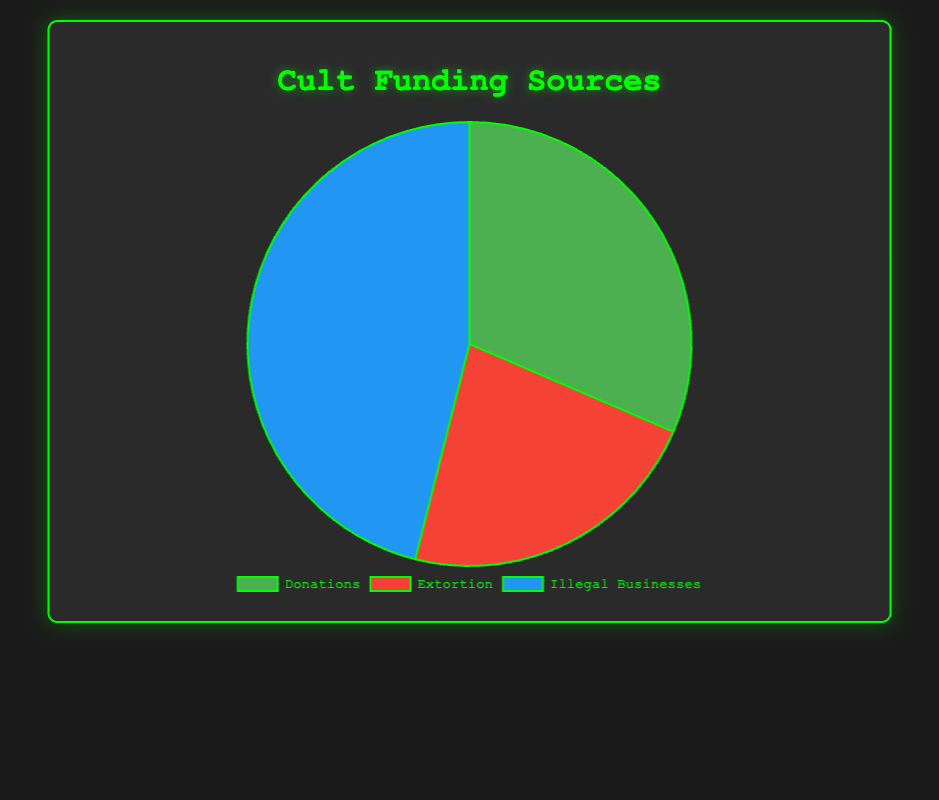what funding category brings in the most money? The pie chart will show the sheer size of each slice, identifying the largest one tells us which category has the highest funding. Look at the slice with the largest area. This represents Illegal Businesses, totaling $410,000.
Answer: Illegal Businesses how much more money does Donations bring in compared to Extortion? First, identify the total amount for Donations ($280,000) and Extortion ($200,000) from the legend. Subtract the Extortion total from the Donations total: 280,000 - 200,000 = 80,000.
Answer: $80,000 what proportion of total funding comes from Illegal Businesses? Sum up all funding sources to get the total: $280,000 (Donations) + $200,000 (Extortion) + $410,000 (Illegal Businesses) = $890,000. The proportion of Illegal Businesses is 410,000 / 890,000 = 0.4607, approximately 46.07%.
Answer: 46.07% which funding source within Illegal Businesses brings in the most money? Within the Illegal Businesses category, check the amounts: Drug Trafficking ($150,000), Human Trafficking ($100,000), Arms Smuggling ($70,000), Counterfeit Goods ($40,000), and Money Laundering ($50,000). The highest amount is for Drug Trafficking.
Answer: Drug Trafficking how does the combined amount from Protection Money and Ransom compare to Individual Donations? Add the amounts for Protection Money ($100,000) and Ransom ($80,000) to get $180,000. Compare this to the amount for Individual Donations ($200,000). Individual Donations are higher.
Answer: Individual Donations are higher what is the funding source with the smallest amount? Identify the smallest individual amount from the list of entities: Charity Events ($30,000), Threatening Letters ($20,000), and Counterfeit Goods ($40,000), etc. Threatening Letters with $20,000 is the smallest.
Answer: Threatening Letters what is the difference between the highest and lowest funding source amounts? Highest amount is Individual Donations ($200,000) and lowest is Threatening Letters ($20,000). Subtract to find the difference: 200,000 - 20,000 = 180,000.
Answer: $180,000 what percentage of Total Funding comes from Donations? Total donations are $280,000. Total funding is $890,000. Calculate the percentage: (280,000 / 890,000) * 100 = 31.46%.
Answer: 31.46% which category has more than twice the funding of Extortion? Determine the amount for Extortion ($200,000). Find categories higher than 200,000 * 2 = 400,000. Only Illegal Businesses with $410,000 fits this.
Answer: Illegal Businesses 